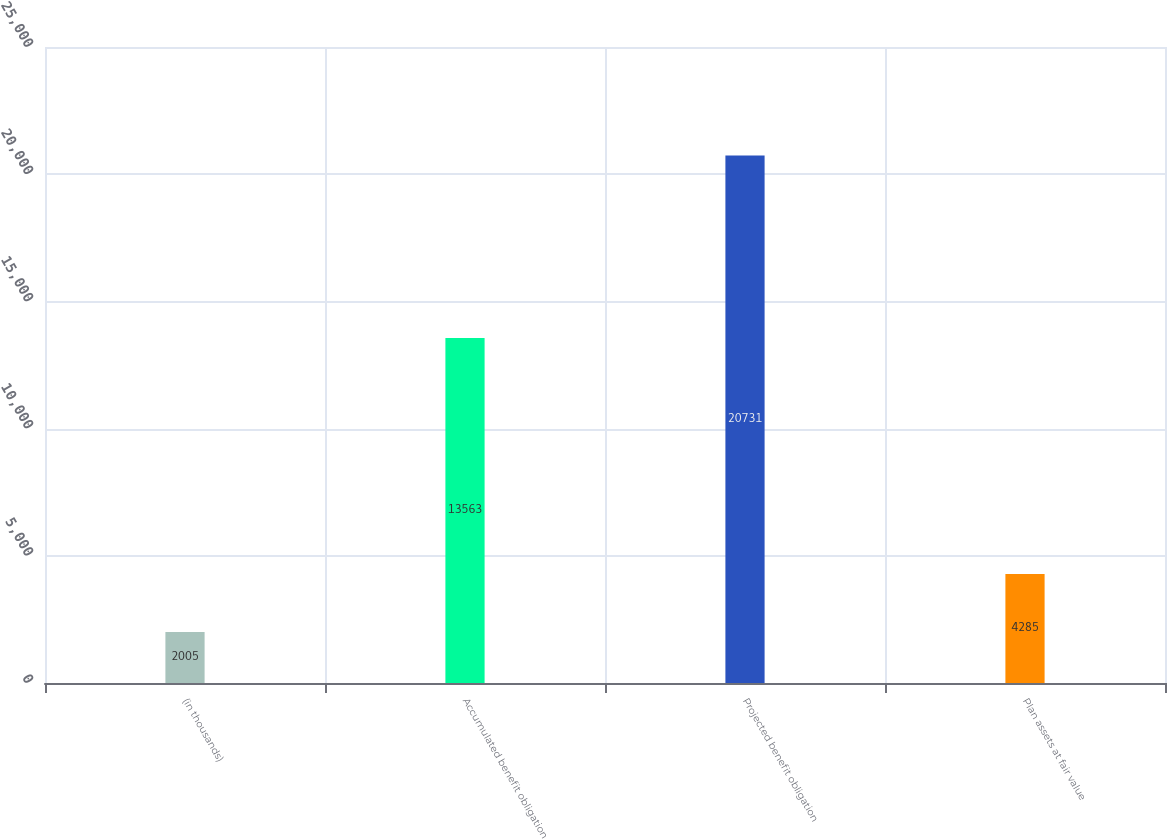Convert chart. <chart><loc_0><loc_0><loc_500><loc_500><bar_chart><fcel>(in thousands)<fcel>Accumulated benefit obligation<fcel>Projected benefit obligation<fcel>Plan assets at fair value<nl><fcel>2005<fcel>13563<fcel>20731<fcel>4285<nl></chart> 